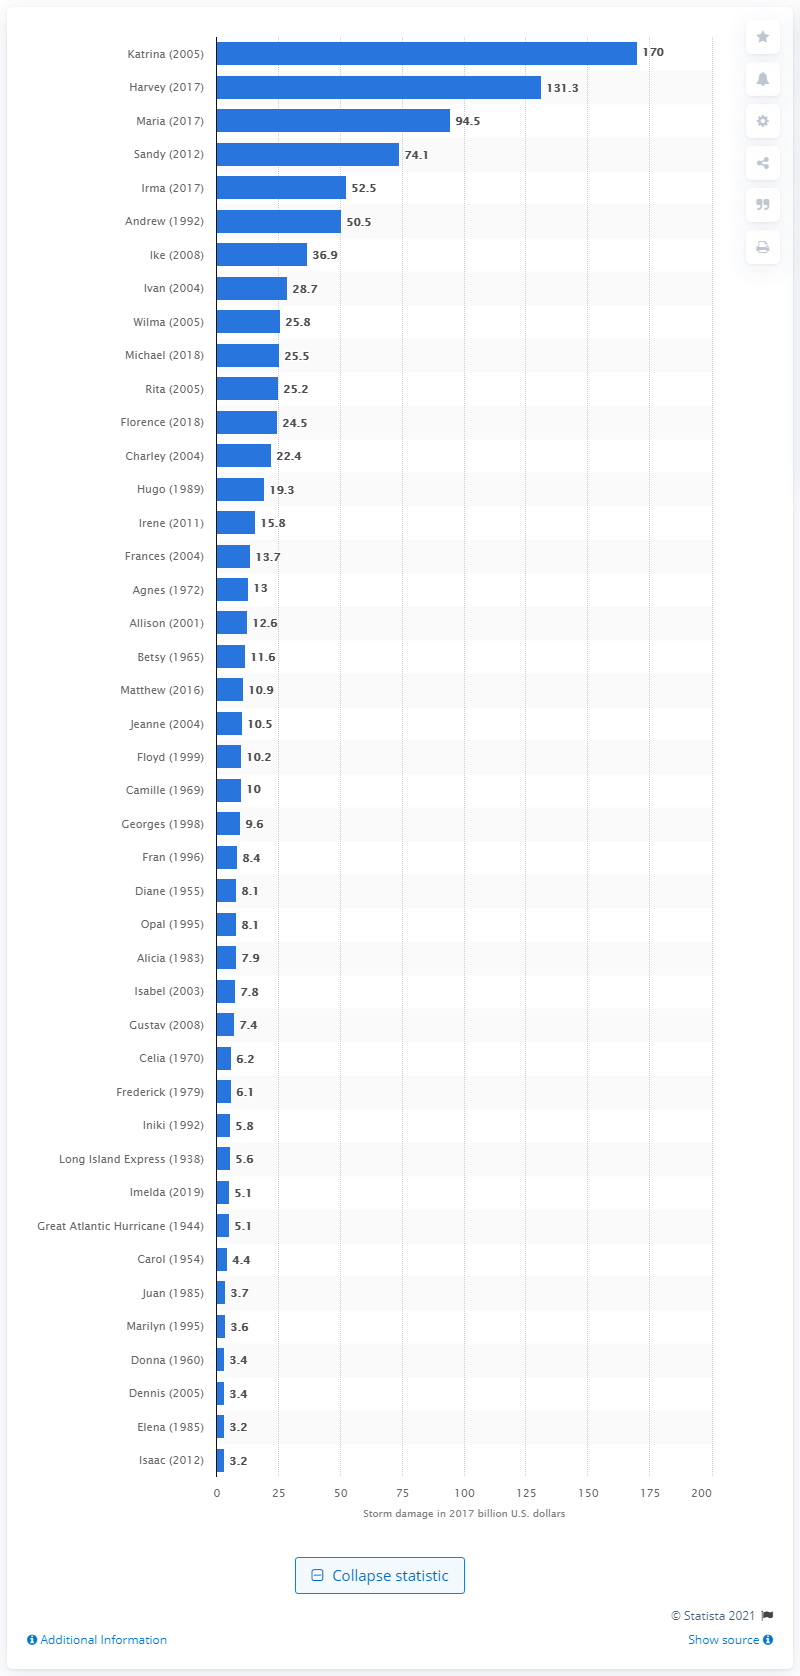Indicate a few pertinent items in this graphic. The cost of Hurricane Katrina in dollars is estimated to be 170. 